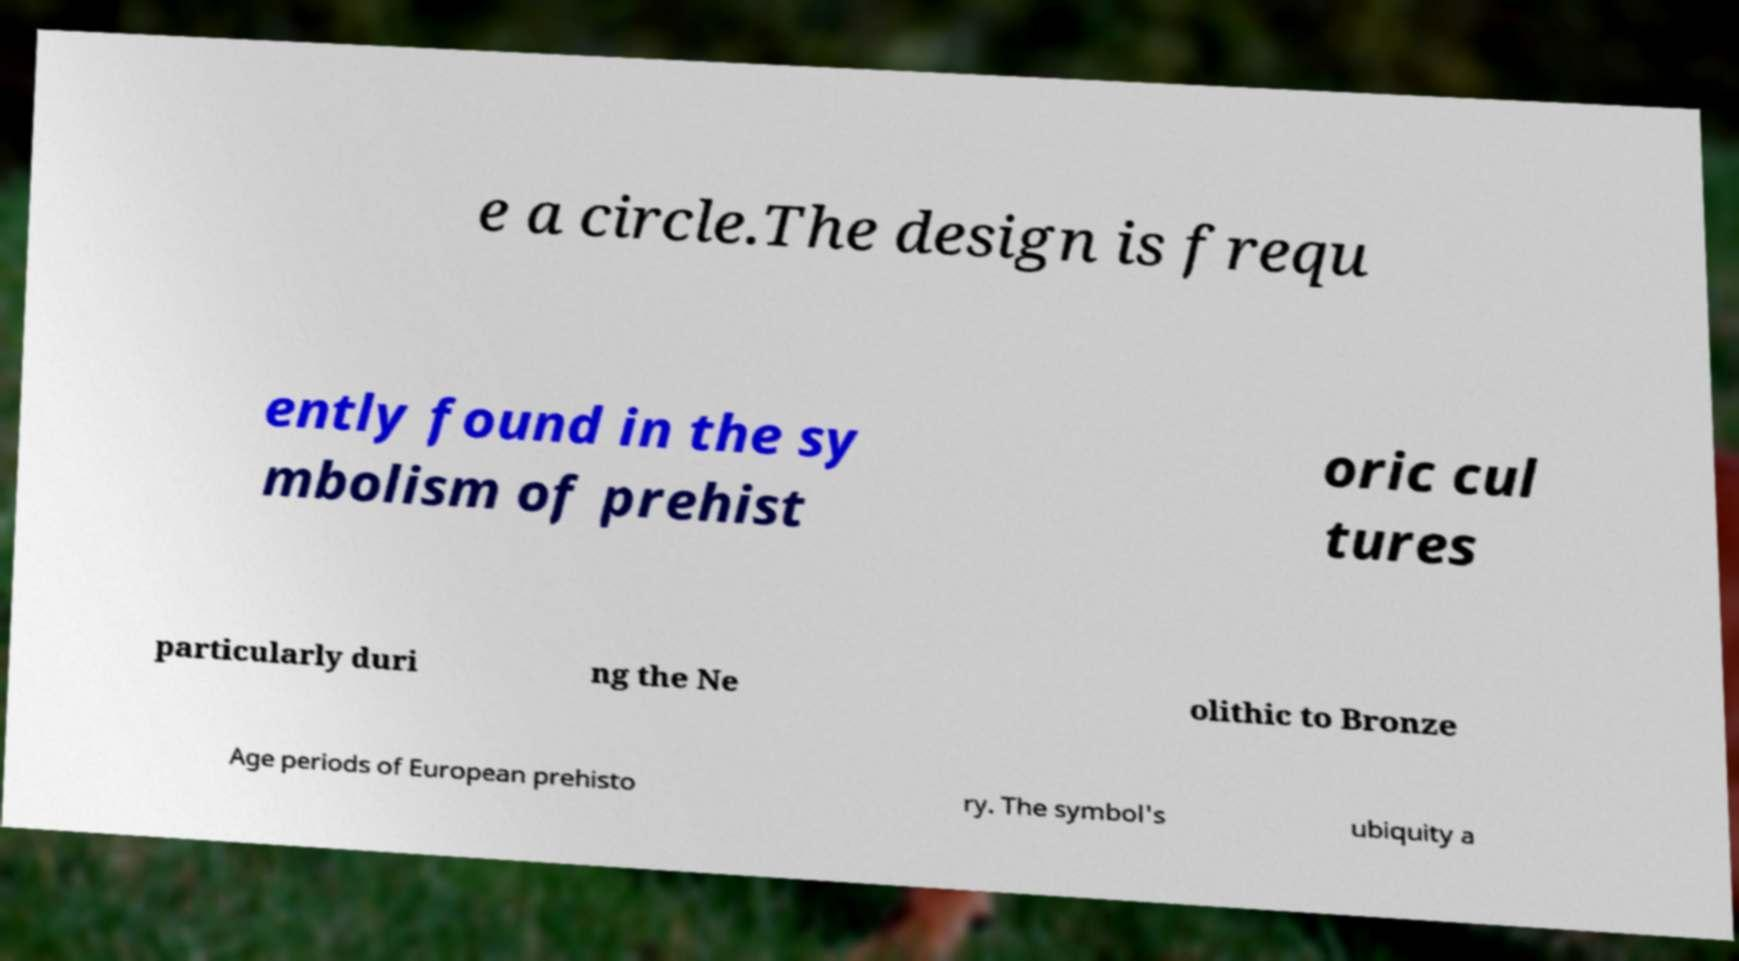I need the written content from this picture converted into text. Can you do that? e a circle.The design is frequ ently found in the sy mbolism of prehist oric cul tures particularly duri ng the Ne olithic to Bronze Age periods of European prehisto ry. The symbol's ubiquity a 